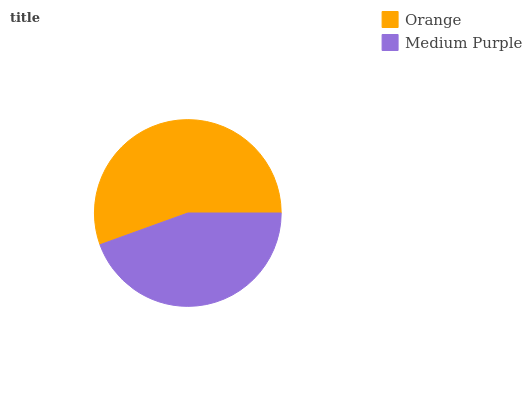Is Medium Purple the minimum?
Answer yes or no. Yes. Is Orange the maximum?
Answer yes or no. Yes. Is Medium Purple the maximum?
Answer yes or no. No. Is Orange greater than Medium Purple?
Answer yes or no. Yes. Is Medium Purple less than Orange?
Answer yes or no. Yes. Is Medium Purple greater than Orange?
Answer yes or no. No. Is Orange less than Medium Purple?
Answer yes or no. No. Is Orange the high median?
Answer yes or no. Yes. Is Medium Purple the low median?
Answer yes or no. Yes. Is Medium Purple the high median?
Answer yes or no. No. Is Orange the low median?
Answer yes or no. No. 